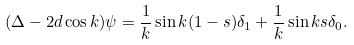Convert formula to latex. <formula><loc_0><loc_0><loc_500><loc_500>( \Delta - 2 d \cos k ) \psi = \frac { 1 } { k } \sin k ( 1 - s ) \delta _ { 1 } + \frac { 1 } { k } \sin k s \delta _ { 0 } .</formula> 